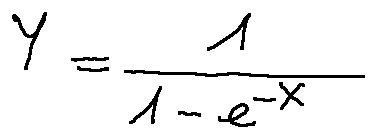<formula> <loc_0><loc_0><loc_500><loc_500>Y = \frac { 1 } { 1 - e ^ { - X } }</formula> 